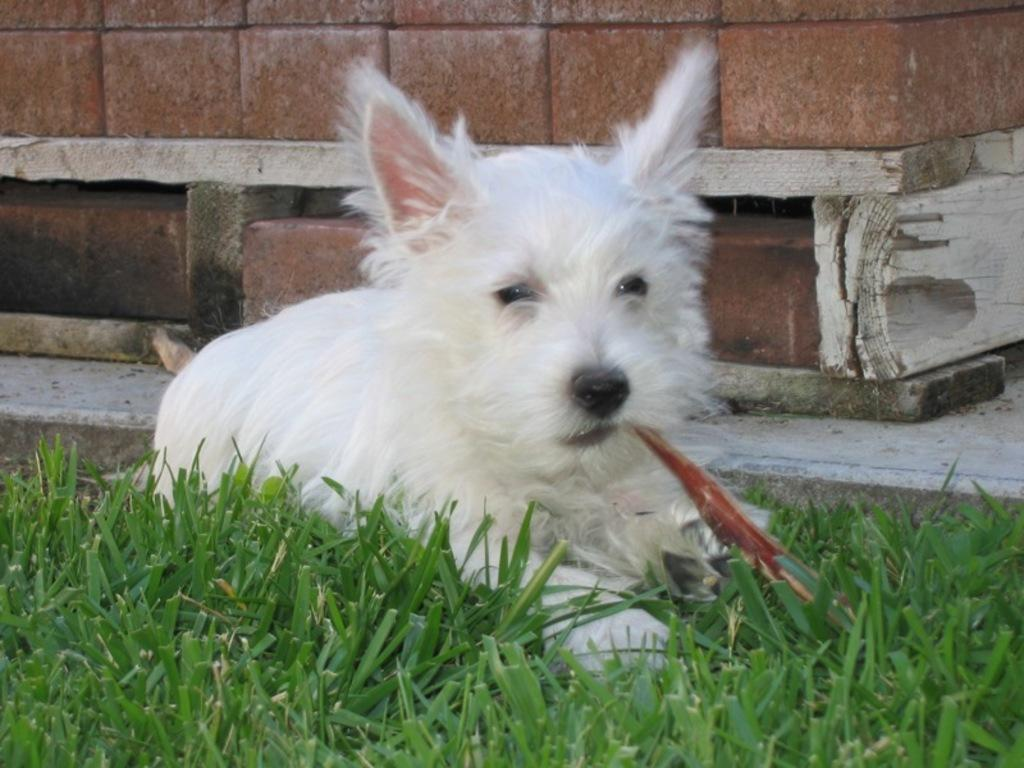What type of animal is present in the image? There is a dog in the image. What is the dog doing in the image? The dog is holding an object in its mouth. What type of environment is visible in the image? There is grass visible in the image. What can be seen in the background of the image? There is a wall in the background of the image. What type of toothbrush is the dog using in the image? There is no toothbrush present in the image, and the dog is not using any such object. 